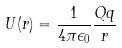<formula> <loc_0><loc_0><loc_500><loc_500>U ( r ) = \frac { 1 } { 4 \pi \epsilon _ { 0 } } \frac { Q q } { r }</formula> 